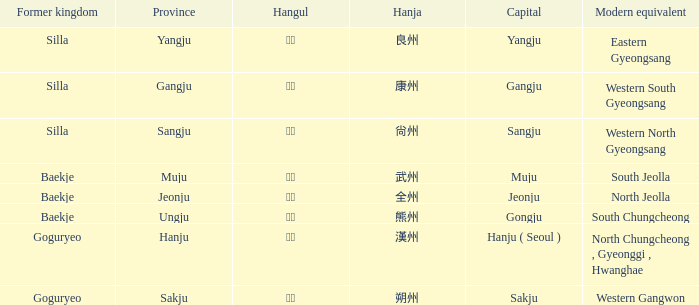What is the hanja for the region of "sangju"? 尙州. 